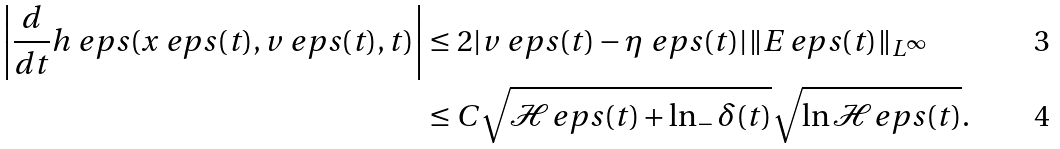Convert formula to latex. <formula><loc_0><loc_0><loc_500><loc_500>\left | \frac { d } { d t } h _ { \ } e p s ( x _ { \ } e p s ( t ) , v _ { \ } e p s ( t ) , t ) \right | & \leq 2 | v _ { \ } e p s ( t ) - \eta _ { \ } e p s ( t ) | \| E _ { \ } e p s ( t ) \| _ { L ^ { \infty } } \\ & \leq C \sqrt { \mathcal { H } _ { \ } e p s ( t ) + \ln _ { - } \delta ( t ) } \sqrt { \ln \mathcal { H } _ { \ } e p s ( t ) } .</formula> 